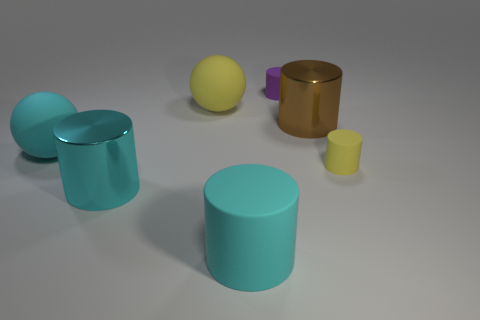Subtract all yellow cylinders. How many cylinders are left? 4 Subtract all purple cylinders. How many cylinders are left? 4 Subtract 1 cylinders. How many cylinders are left? 4 Subtract all green cylinders. Subtract all gray balls. How many cylinders are left? 5 Add 3 big cyan spheres. How many objects exist? 10 Subtract all cylinders. How many objects are left? 2 Subtract all cyan balls. Subtract all yellow things. How many objects are left? 4 Add 5 large yellow balls. How many large yellow balls are left? 6 Add 5 purple matte objects. How many purple matte objects exist? 6 Subtract 0 brown spheres. How many objects are left? 7 